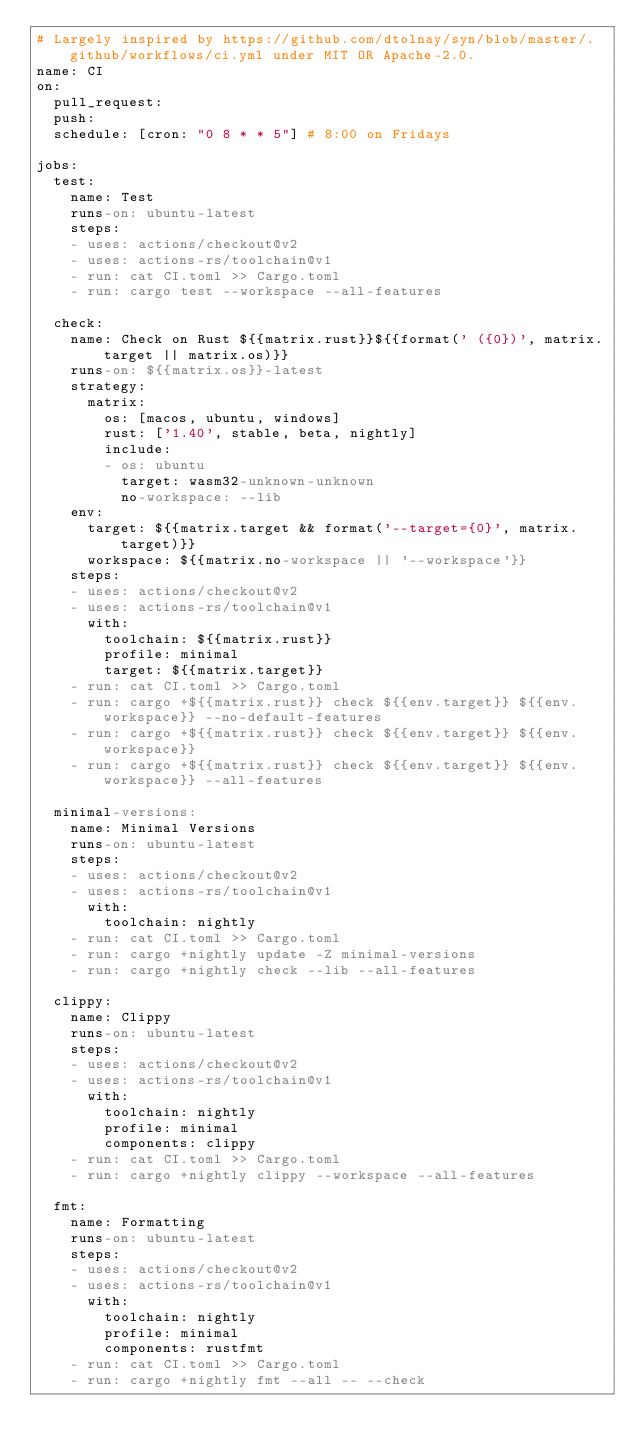<code> <loc_0><loc_0><loc_500><loc_500><_YAML_># Largely inspired by https://github.com/dtolnay/syn/blob/master/.github/workflows/ci.yml under MIT OR Apache-2.0.
name: CI
on:
  pull_request:
  push:
  schedule: [cron: "0 8 * * 5"] # 8:00 on Fridays

jobs:
  test:
    name: Test
    runs-on: ubuntu-latest
    steps:
    - uses: actions/checkout@v2
    - uses: actions-rs/toolchain@v1
    - run: cat CI.toml >> Cargo.toml
    - run: cargo test --workspace --all-features

  check:
    name: Check on Rust ${{matrix.rust}}${{format(' ({0})', matrix.target || matrix.os)}}
    runs-on: ${{matrix.os}}-latest
    strategy:
      matrix:
        os: [macos, ubuntu, windows]
        rust: ['1.40', stable, beta, nightly]
        include:
        - os: ubuntu
          target: wasm32-unknown-unknown
          no-workspace: --lib
    env:
      target: ${{matrix.target && format('--target={0}', matrix.target)}}
      workspace: ${{matrix.no-workspace || '--workspace'}}
    steps:
    - uses: actions/checkout@v2
    - uses: actions-rs/toolchain@v1
      with:
        toolchain: ${{matrix.rust}}
        profile: minimal
        target: ${{matrix.target}}
    - run: cat CI.toml >> Cargo.toml
    - run: cargo +${{matrix.rust}} check ${{env.target}} ${{env.workspace}} --no-default-features
    - run: cargo +${{matrix.rust}} check ${{env.target}} ${{env.workspace}}
    - run: cargo +${{matrix.rust}} check ${{env.target}} ${{env.workspace}} --all-features

  minimal-versions:
    name: Minimal Versions
    runs-on: ubuntu-latest
    steps:
    - uses: actions/checkout@v2
    - uses: actions-rs/toolchain@v1
      with:
        toolchain: nightly
    - run: cat CI.toml >> Cargo.toml
    - run: cargo +nightly update -Z minimal-versions
    - run: cargo +nightly check --lib --all-features

  clippy:
    name: Clippy
    runs-on: ubuntu-latest
    steps:
    - uses: actions/checkout@v2
    - uses: actions-rs/toolchain@v1
      with:
        toolchain: nightly
        profile: minimal
        components: clippy
    - run: cat CI.toml >> Cargo.toml
    - run: cargo +nightly clippy --workspace --all-features

  fmt:
    name: Formatting
    runs-on: ubuntu-latest
    steps:
    - uses: actions/checkout@v2
    - uses: actions-rs/toolchain@v1
      with:
        toolchain: nightly
        profile: minimal
        components: rustfmt
    - run: cat CI.toml >> Cargo.toml
    - run: cargo +nightly fmt --all -- --check
</code> 